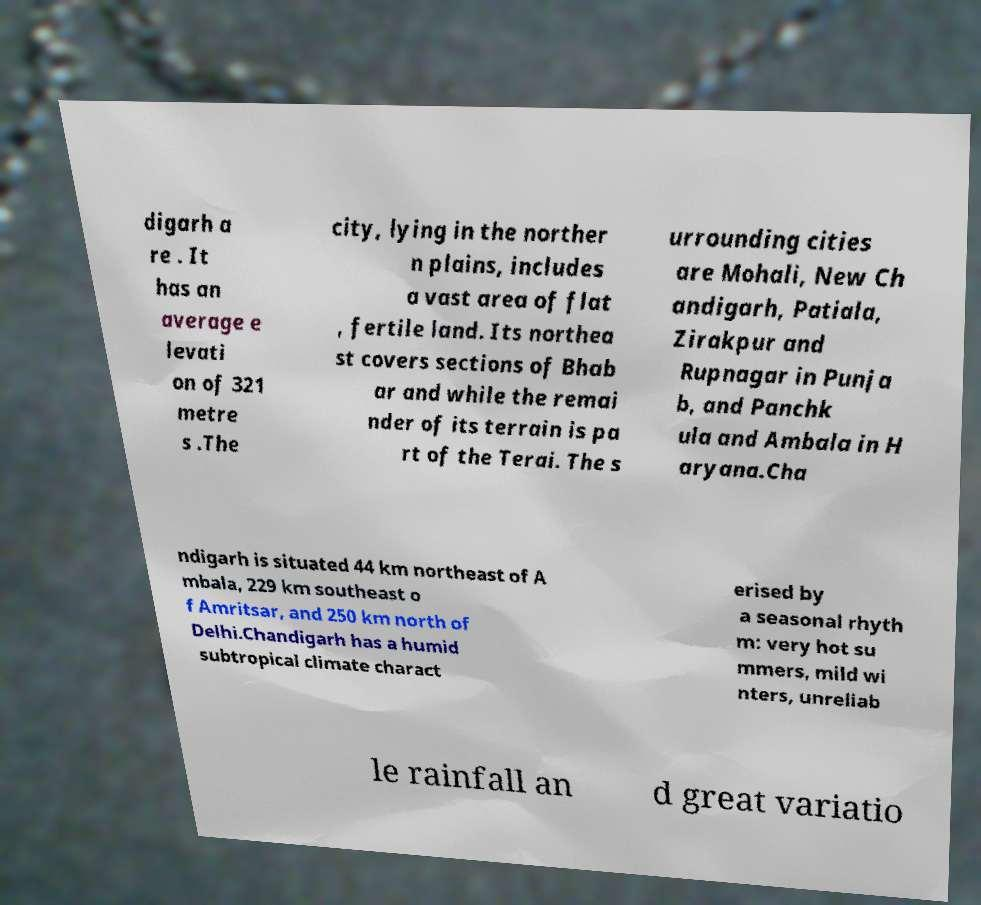Could you extract and type out the text from this image? digarh a re . It has an average e levati on of 321 metre s .The city, lying in the norther n plains, includes a vast area of flat , fertile land. Its northea st covers sections of Bhab ar and while the remai nder of its terrain is pa rt of the Terai. The s urrounding cities are Mohali, New Ch andigarh, Patiala, Zirakpur and Rupnagar in Punja b, and Panchk ula and Ambala in H aryana.Cha ndigarh is situated 44 km northeast of A mbala, 229 km southeast o f Amritsar, and 250 km north of Delhi.Chandigarh has a humid subtropical climate charact erised by a seasonal rhyth m: very hot su mmers, mild wi nters, unreliab le rainfall an d great variatio 